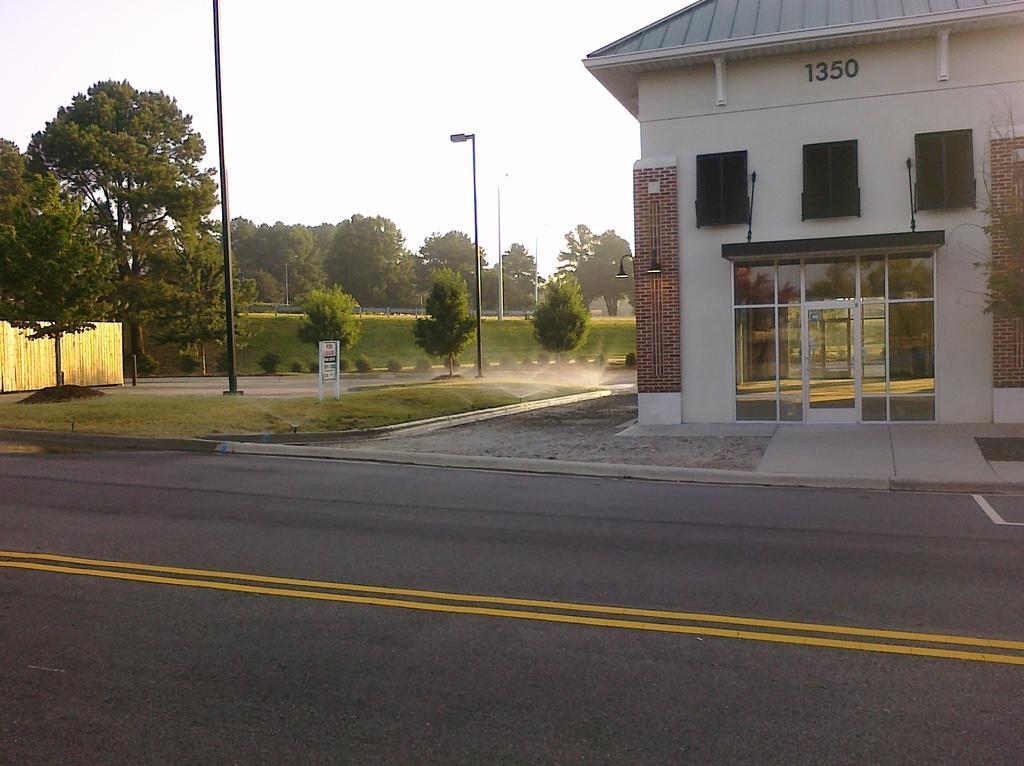In one or two sentences, can you explain what this image depicts? In this image I see a building over here and I see numbers on the wall and I see the footpath, road on which there are yellow lines and I see the grass and the trees and I can also see few poles and I see a board over here and I see the sprinklers over here. In the background I see the sky. 